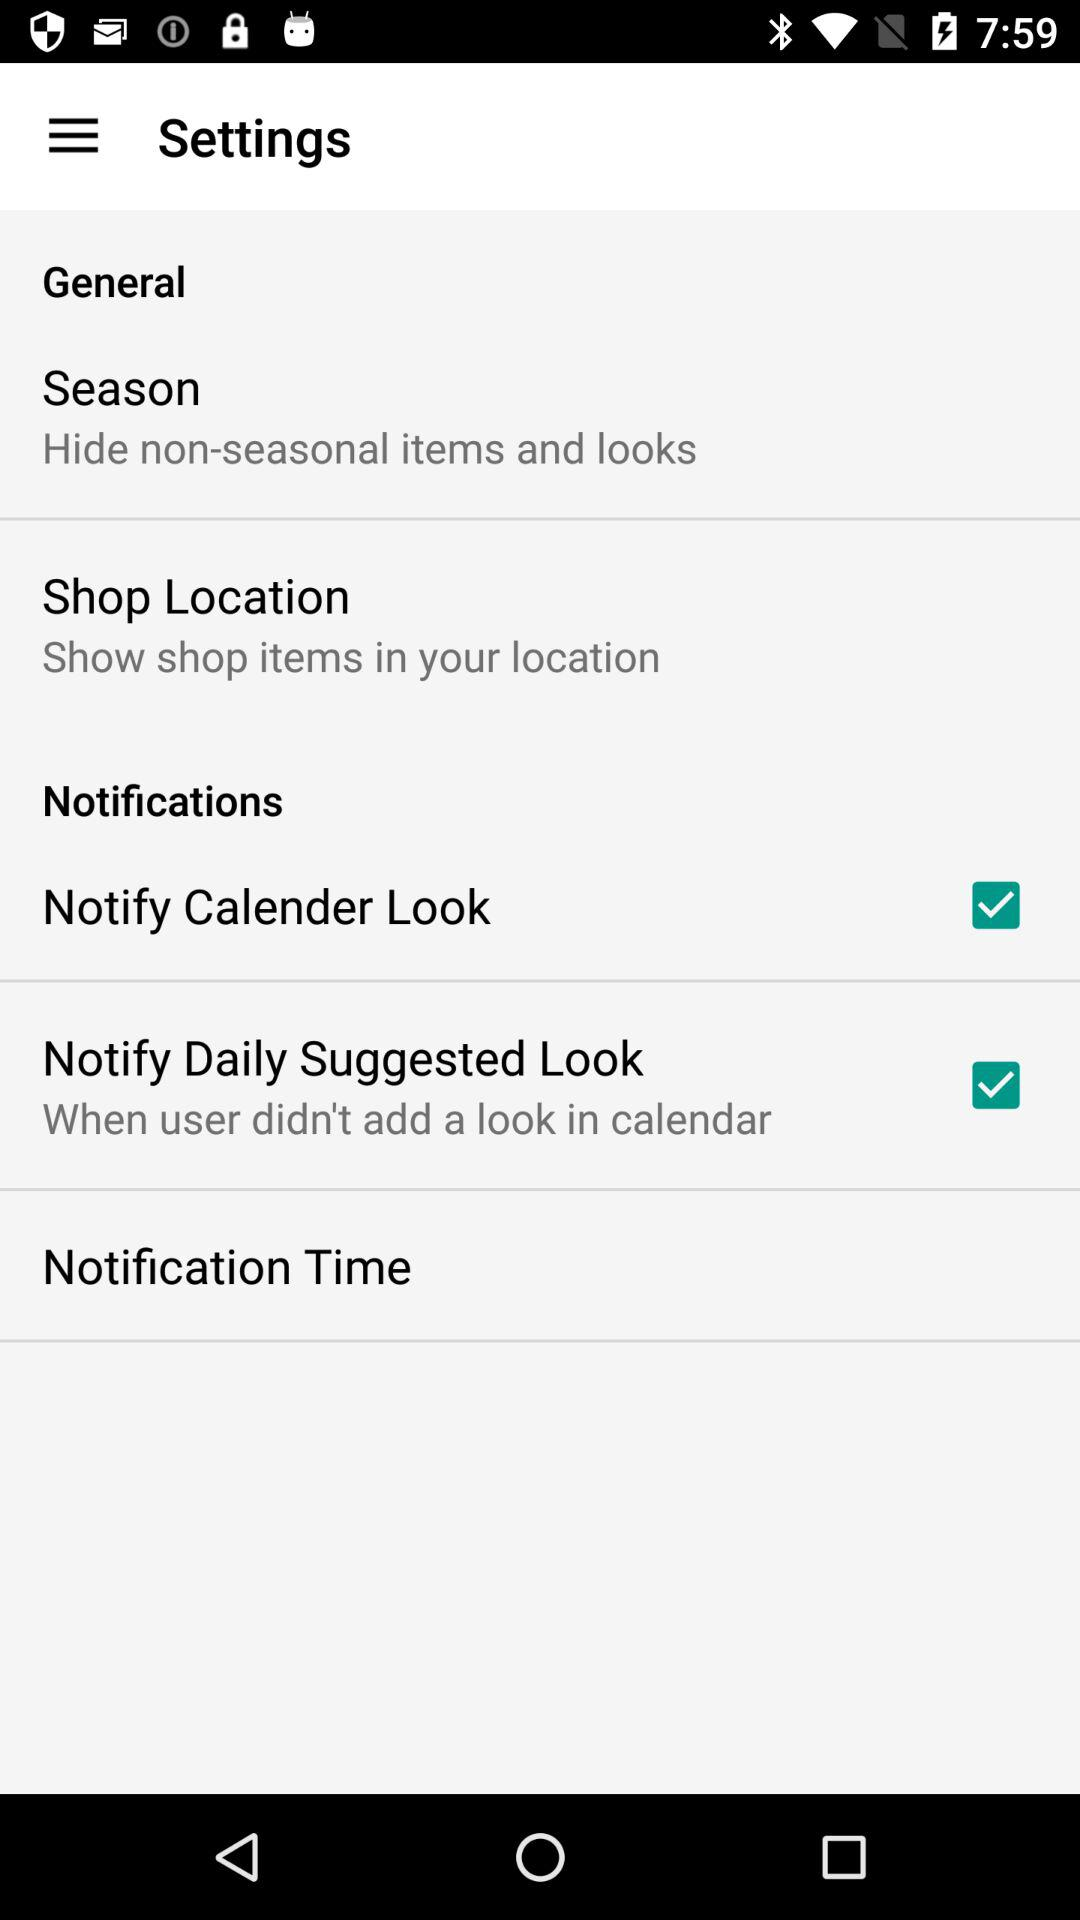How many items are in the General section?
Answer the question using a single word or phrase. 2 